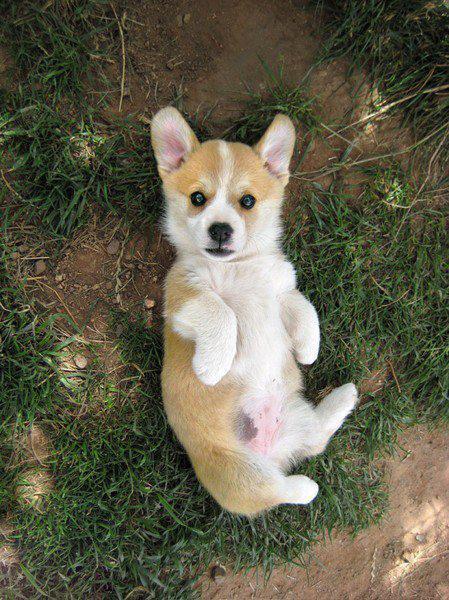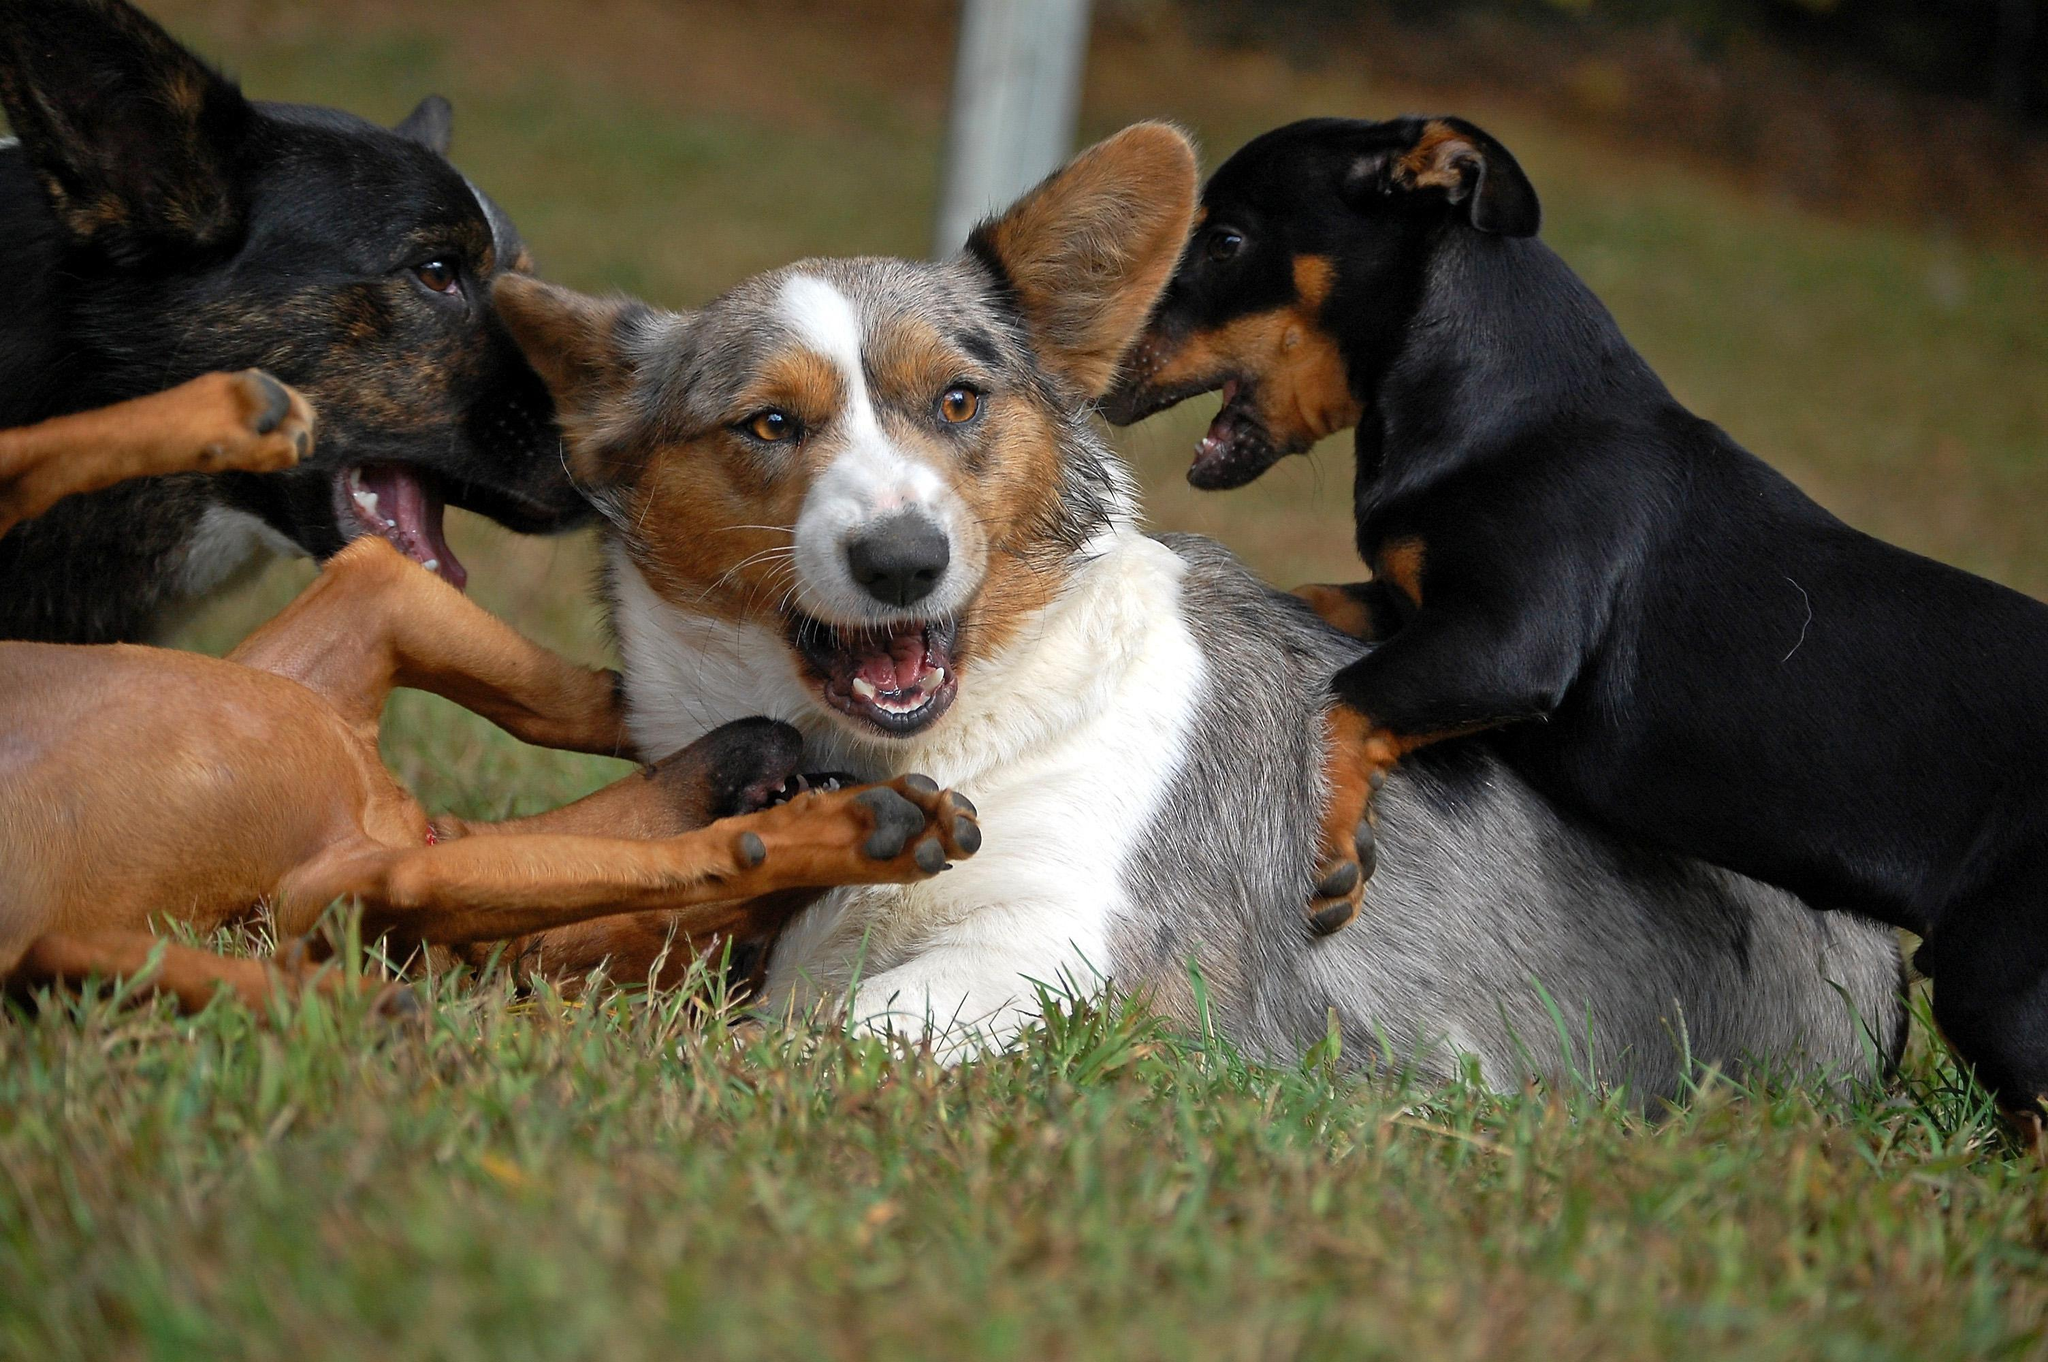The first image is the image on the left, the second image is the image on the right. For the images displayed, is the sentence "Each image shows exactly one short-legged dog standing in the grass." factually correct? Answer yes or no. No. The first image is the image on the left, the second image is the image on the right. Considering the images on both sides, is "There are at least three dogs in a grassy area." valid? Answer yes or no. Yes. 